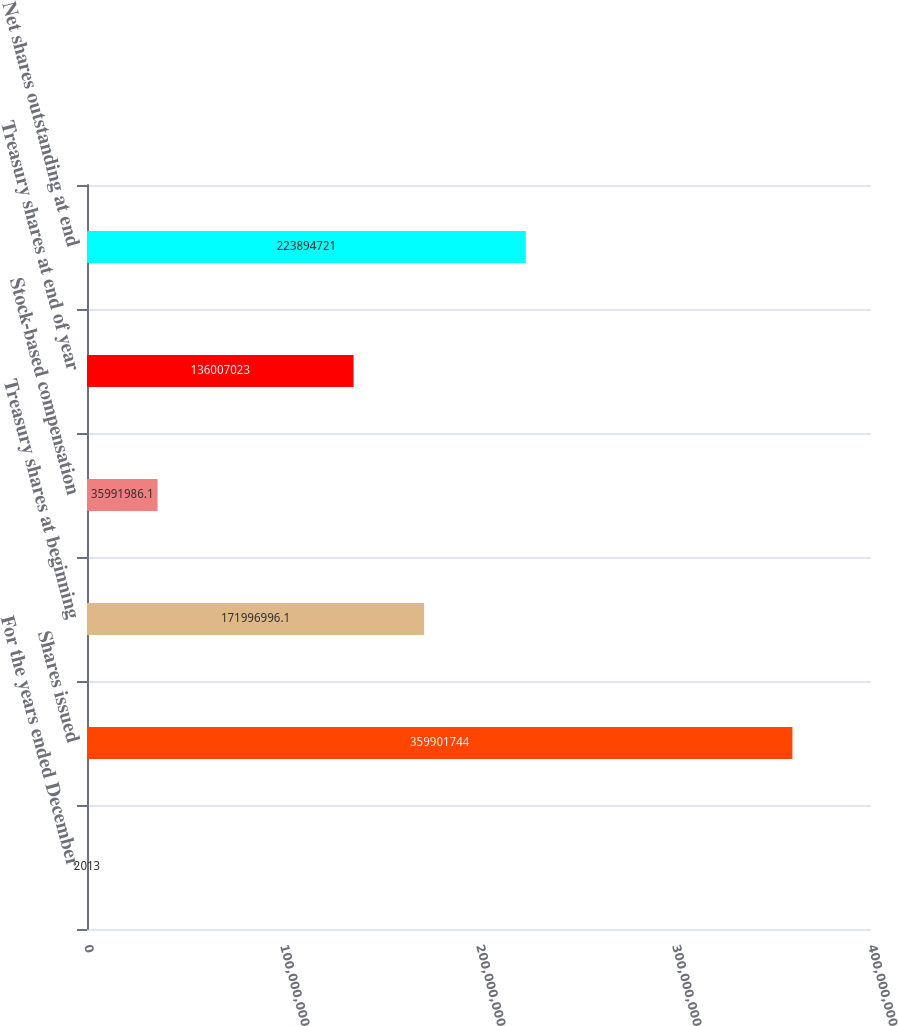Convert chart. <chart><loc_0><loc_0><loc_500><loc_500><bar_chart><fcel>For the years ended December<fcel>Shares issued<fcel>Treasury shares at beginning<fcel>Stock-based compensation<fcel>Treasury shares at end of year<fcel>Net shares outstanding at end<nl><fcel>2013<fcel>3.59902e+08<fcel>1.71997e+08<fcel>3.5992e+07<fcel>1.36007e+08<fcel>2.23895e+08<nl></chart> 